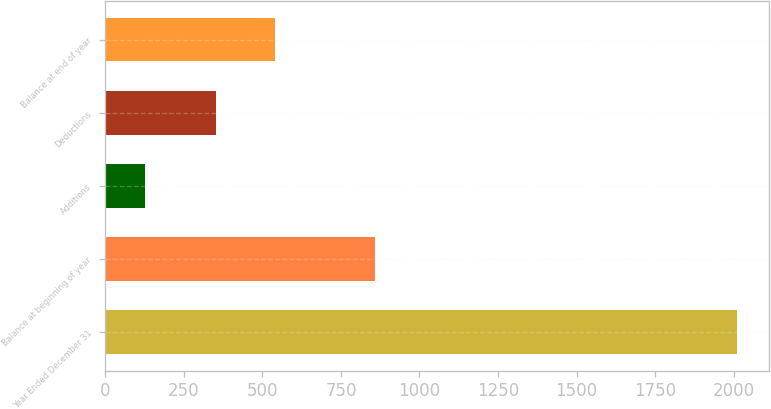<chart> <loc_0><loc_0><loc_500><loc_500><bar_chart><fcel>Year Ended December 31<fcel>Balance at beginning of year<fcel>Additions<fcel>Deductions<fcel>Balance at end of year<nl><fcel>2012<fcel>859<fcel>126<fcel>352<fcel>540.6<nl></chart> 